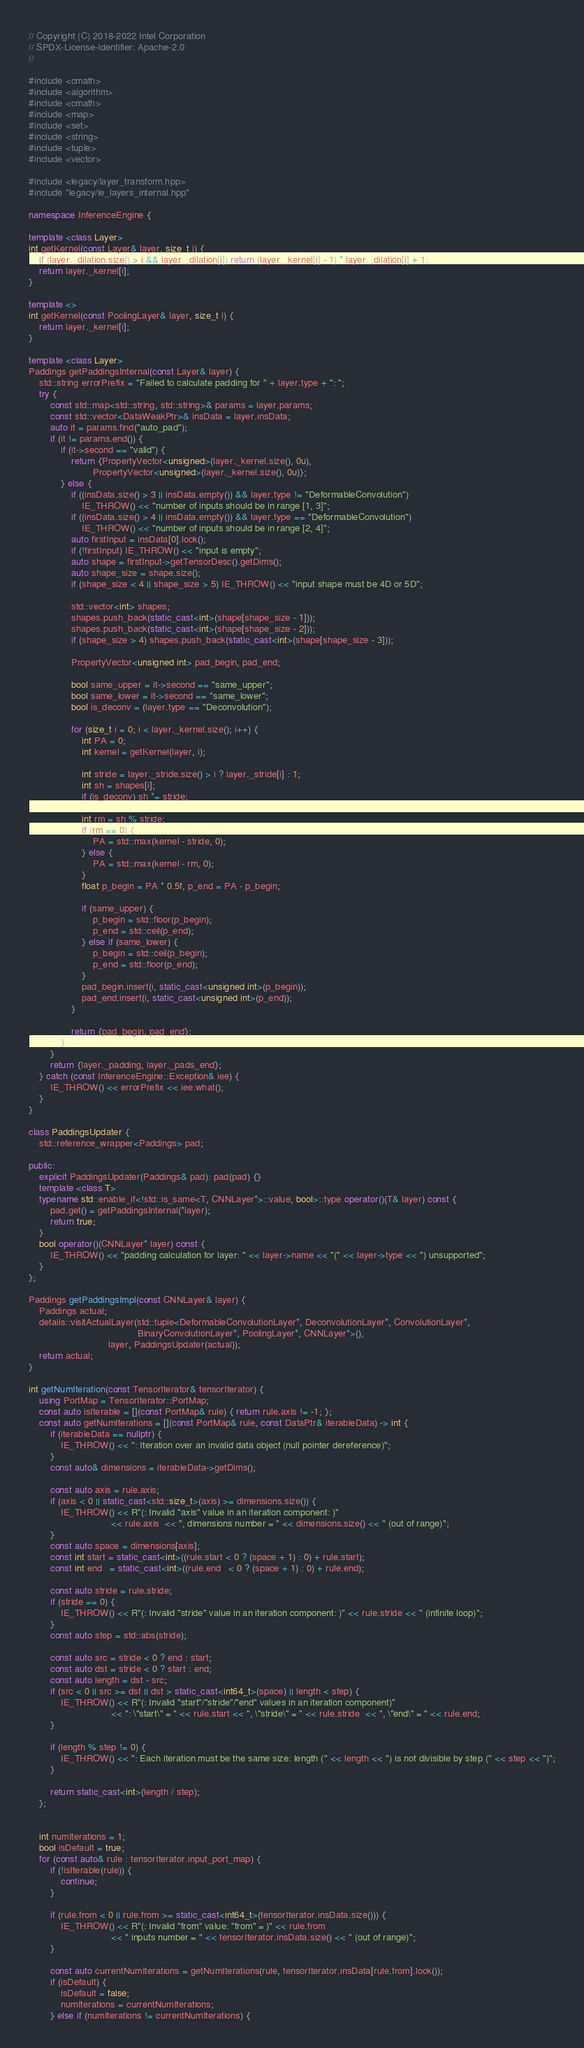<code> <loc_0><loc_0><loc_500><loc_500><_C++_>// Copyright (C) 2018-2022 Intel Corporation
// SPDX-License-Identifier: Apache-2.0
//

#include <cmath>
#include <algorithm>
#include <cmath>
#include <map>
#include <set>
#include <string>
#include <tuple>
#include <vector>

#include <legacy/layer_transform.hpp>
#include "legacy/ie_layers_internal.hpp"

namespace InferenceEngine {

template <class Layer>
int getKernel(const Layer& layer, size_t i) {
    if (layer._dilation.size() > i && layer._dilation[i]) return (layer._kernel[i] - 1) * layer._dilation[i] + 1;
    return layer._kernel[i];
}

template <>
int getKernel(const PoolingLayer& layer, size_t i) {
    return layer._kernel[i];
}

template <class Layer>
Paddings getPaddingsInternal(const Layer& layer) {
    std::string errorPrefix = "Failed to calculate padding for " + layer.type + ": ";
    try {
        const std::map<std::string, std::string>& params = layer.params;
        const std::vector<DataWeakPtr>& insData = layer.insData;
        auto it = params.find("auto_pad");
        if (it != params.end()) {
            if (it->second == "valid") {
                return {PropertyVector<unsigned>(layer._kernel.size(), 0u),
                        PropertyVector<unsigned>(layer._kernel.size(), 0u)};
            } else {
                if ((insData.size() > 3 || insData.empty()) && layer.type != "DeformableConvolution")
                    IE_THROW() << "number of inputs should be in range [1, 3]";
                if ((insData.size() > 4 || insData.empty()) && layer.type == "DeformableConvolution")
                    IE_THROW() << "number of inputs should be in range [2, 4]";
                auto firstInput = insData[0].lock();
                if (!firstInput) IE_THROW() << "input is empty";
                auto shape = firstInput->getTensorDesc().getDims();
                auto shape_size = shape.size();
                if (shape_size < 4 || shape_size > 5) IE_THROW() << "input shape must be 4D or 5D";

                std::vector<int> shapes;
                shapes.push_back(static_cast<int>(shape[shape_size - 1]));
                shapes.push_back(static_cast<int>(shape[shape_size - 2]));
                if (shape_size > 4) shapes.push_back(static_cast<int>(shape[shape_size - 3]));

                PropertyVector<unsigned int> pad_begin, pad_end;

                bool same_upper = it->second == "same_upper";
                bool same_lower = it->second == "same_lower";
                bool is_deconv = (layer.type == "Deconvolution");

                for (size_t i = 0; i < layer._kernel.size(); i++) {
                    int PA = 0;
                    int kernel = getKernel(layer, i);

                    int stride = layer._stride.size() > i ? layer._stride[i] : 1;
                    int sh = shapes[i];
                    if (is_deconv) sh *= stride;

                    int rm = sh % stride;
                    if (rm == 0) {
                        PA = std::max(kernel - stride, 0);
                    } else {
                        PA = std::max(kernel - rm, 0);
                    }
                    float p_begin = PA * 0.5f, p_end = PA - p_begin;

                    if (same_upper) {
                        p_begin = std::floor(p_begin);
                        p_end = std::ceil(p_end);
                    } else if (same_lower) {
                        p_begin = std::ceil(p_begin);
                        p_end = std::floor(p_end);
                    }
                    pad_begin.insert(i, static_cast<unsigned int>(p_begin));
                    pad_end.insert(i, static_cast<unsigned int>(p_end));
                }

                return {pad_begin, pad_end};
            }
        }
        return {layer._padding, layer._pads_end};
    } catch (const InferenceEngine::Exception& iee) {
        IE_THROW() << errorPrefix << iee.what();
    }
}

class PaddingsUpdater {
    std::reference_wrapper<Paddings> pad;

public:
    explicit PaddingsUpdater(Paddings& pad): pad(pad) {}
    template <class T>
    typename std::enable_if<!std::is_same<T, CNNLayer*>::value, bool>::type operator()(T& layer) const {
        pad.get() = getPaddingsInternal(*layer);
        return true;
    }
    bool operator()(CNNLayer* layer) const {
        IE_THROW() << "padding calculation for layer: " << layer->name << "(" << layer->type << ") unsupported";
    }
};

Paddings getPaddingsImpl(const CNNLayer& layer) {
    Paddings actual;
    details::visitActualLayer(std::tuple<DeformableConvolutionLayer*, DeconvolutionLayer*, ConvolutionLayer*,
                                         BinaryConvolutionLayer*, PoolingLayer*, CNNLayer*>(),
                              layer, PaddingsUpdater(actual));
    return actual;
}

int getNumIteration(const TensorIterator& tensorIterator) {
    using PortMap = TensorIterator::PortMap;
    const auto isIterable = [](const PortMap& rule) { return rule.axis != -1; };
    const auto getNumIterations = [](const PortMap& rule, const DataPtr& iterableData) -> int {
        if (iterableData == nullptr) {
            IE_THROW() << ": Iteration over an invalid data object (null pointer dereference)";
        }
        const auto& dimensions = iterableData->getDims();

        const auto axis = rule.axis;
        if (axis < 0 || static_cast<std::size_t>(axis) >= dimensions.size()) {
            IE_THROW() << R"(: Invalid "axis" value in an iteration component: )"
                               << rule.axis  << ", dimensions number = " << dimensions.size() << " (out of range)";
        }
        const auto space = dimensions[axis];
        const int start = static_cast<int>((rule.start < 0 ? (space + 1) : 0) + rule.start);
        const int end   = static_cast<int>((rule.end   < 0 ? (space + 1) : 0) + rule.end);

        const auto stride = rule.stride;
        if (stride == 0) {
            IE_THROW() << R"(: Invalid "stride" value in an iteration component: )" << rule.stride << " (infinite loop)";
        }
        const auto step = std::abs(stride);

        const auto src = stride < 0 ? end : start;
        const auto dst = stride < 0 ? start : end;
        const auto length = dst - src;
        if (src < 0 || src >= dst || dst > static_cast<int64_t>(space) || length < step) {
            IE_THROW() << R"(: Invalid "start"/"stride"/"end" values in an iteration component)"
                               << ": \"start\" = " << rule.start << ", \"stride\" = " << rule.stride  << ", \"end\" = " << rule.end;
        }

        if (length % step != 0) {
            IE_THROW() << ": Each iteration must be the same size: length (" << length << ") is not divisible by step (" << step << ")";
        }

        return static_cast<int>(length / step);
    };


    int numIterations = 1;
    bool isDefault = true;
    for (const auto& rule : tensorIterator.input_port_map) {
        if (!isIterable(rule)) {
            continue;
        }

        if (rule.from < 0 || rule.from >= static_cast<int64_t>(tensorIterator.insData.size())) {
            IE_THROW() << R"(: Invalid "from" value: "from" = )" << rule.from
                               << " inputs number = " << tensorIterator.insData.size() << " (out of range)";
        }

        const auto currentNumIterations = getNumIterations(rule, tensorIterator.insData[rule.from].lock());
        if (isDefault) {
            isDefault = false;
            numIterations = currentNumIterations;
        } else if (numIterations != currentNumIterations) {</code> 